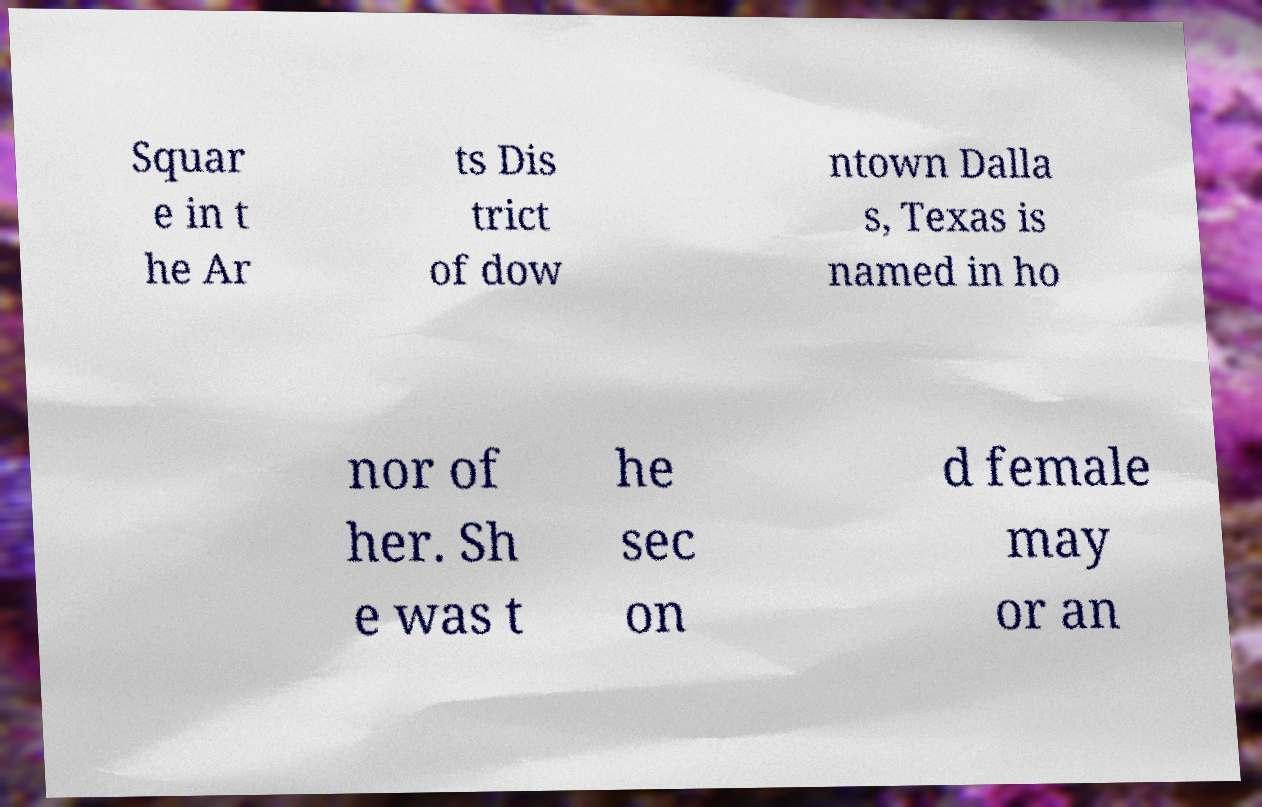For documentation purposes, I need the text within this image transcribed. Could you provide that? Squar e in t he Ar ts Dis trict of dow ntown Dalla s, Texas is named in ho nor of her. Sh e was t he sec on d female may or an 